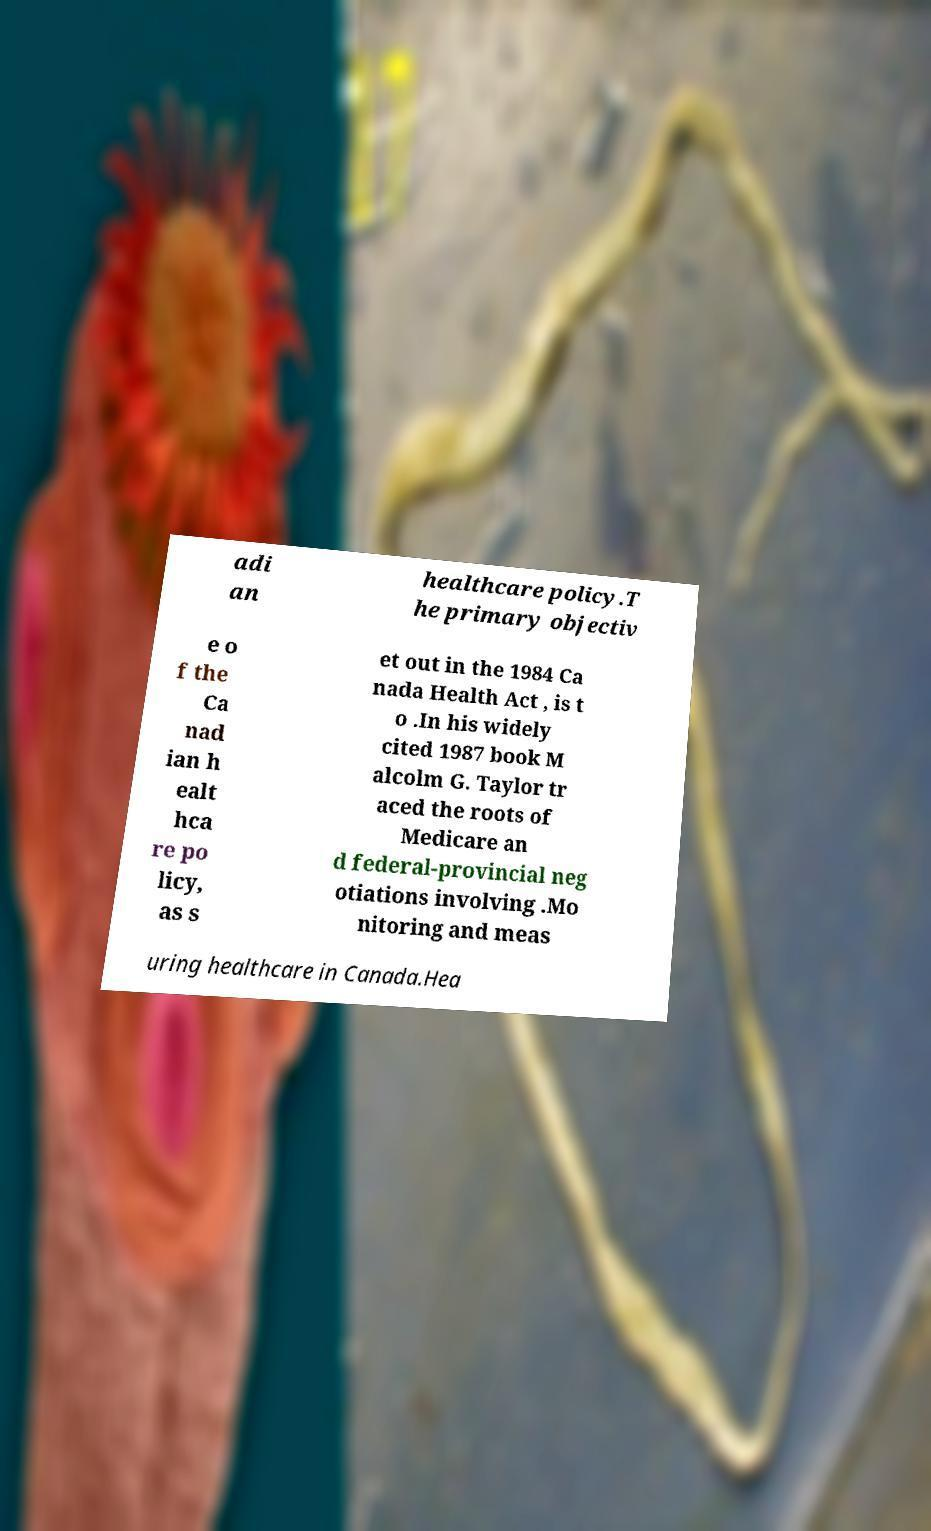There's text embedded in this image that I need extracted. Can you transcribe it verbatim? adi an healthcare policy.T he primary objectiv e o f the Ca nad ian h ealt hca re po licy, as s et out in the 1984 Ca nada Health Act , is t o .In his widely cited 1987 book M alcolm G. Taylor tr aced the roots of Medicare an d federal-provincial neg otiations involving .Mo nitoring and meas uring healthcare in Canada.Hea 